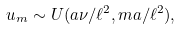<formula> <loc_0><loc_0><loc_500><loc_500>u _ { m } \sim U ( a \nu / \ell ^ { 2 } , m a / \ell ^ { 2 } ) ,</formula> 